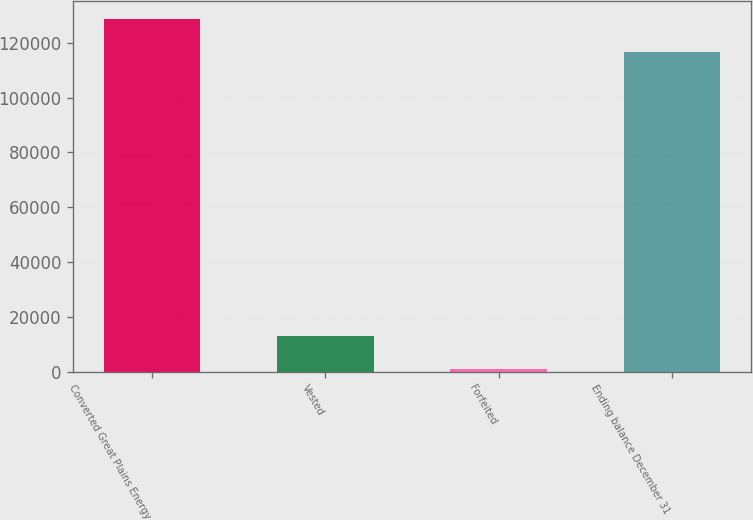Convert chart to OTSL. <chart><loc_0><loc_0><loc_500><loc_500><bar_chart><fcel>Converted Great Plains Energy<fcel>Vested<fcel>Forfeited<fcel>Ending balance December 31<nl><fcel>128818<fcel>13213.5<fcel>1070<fcel>116675<nl></chart> 